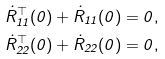Convert formula to latex. <formula><loc_0><loc_0><loc_500><loc_500>\dot { R } _ { 1 1 } ^ { \top } ( 0 ) + \dot { R } _ { 1 1 } ( 0 ) = 0 , \\ \dot { R } _ { 2 2 } ^ { \top } ( 0 ) + \dot { R } _ { 2 2 } ( 0 ) = 0 ,</formula> 